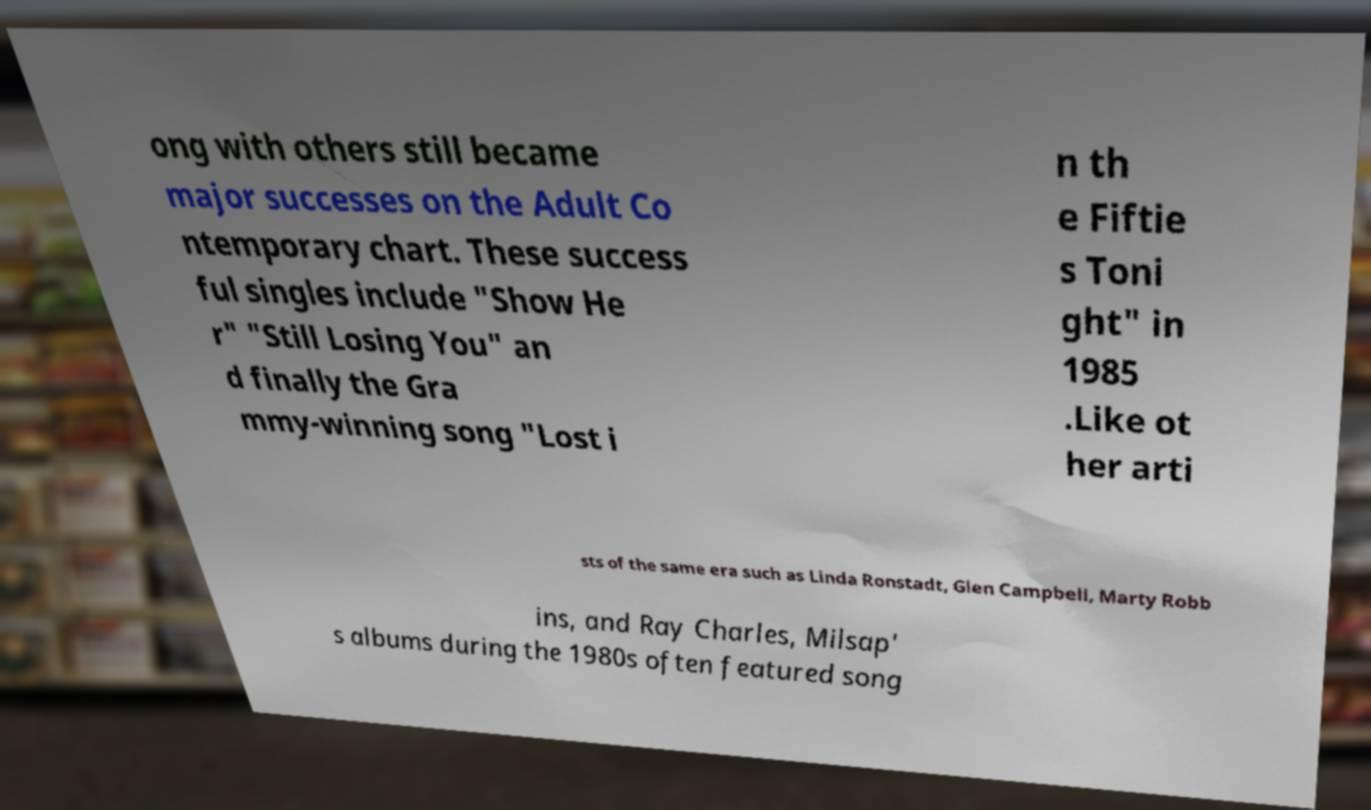Could you assist in decoding the text presented in this image and type it out clearly? ong with others still became major successes on the Adult Co ntemporary chart. These success ful singles include "Show He r" "Still Losing You" an d finally the Gra mmy-winning song "Lost i n th e Fiftie s Toni ght" in 1985 .Like ot her arti sts of the same era such as Linda Ronstadt, Glen Campbell, Marty Robb ins, and Ray Charles, Milsap' s albums during the 1980s often featured song 